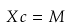<formula> <loc_0><loc_0><loc_500><loc_500>X c = M</formula> 